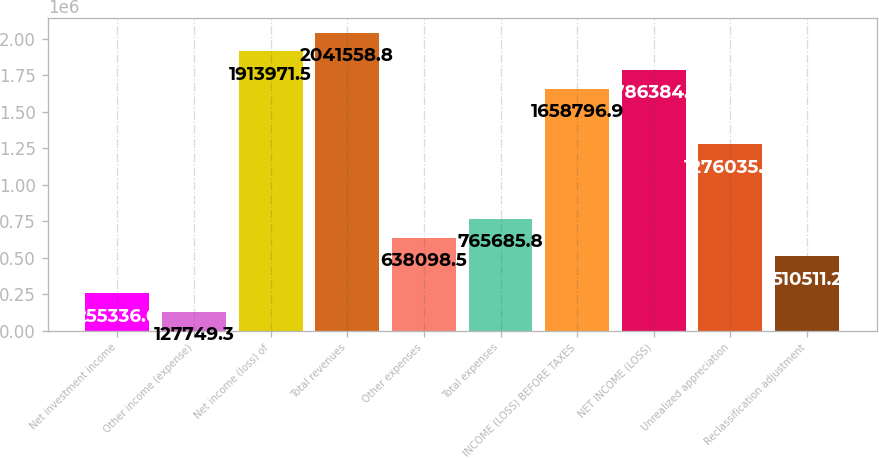Convert chart. <chart><loc_0><loc_0><loc_500><loc_500><bar_chart><fcel>Net investment income<fcel>Other income (expense)<fcel>Net income (loss) of<fcel>Total revenues<fcel>Other expenses<fcel>Total expenses<fcel>INCOME (LOSS) BEFORE TAXES<fcel>NET INCOME (LOSS)<fcel>Unrealized appreciation<fcel>Reclassification adjustment<nl><fcel>255337<fcel>127749<fcel>1.91397e+06<fcel>2.04156e+06<fcel>638098<fcel>765686<fcel>1.6588e+06<fcel>1.78638e+06<fcel>1.27604e+06<fcel>510511<nl></chart> 